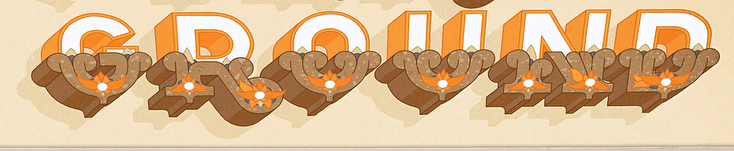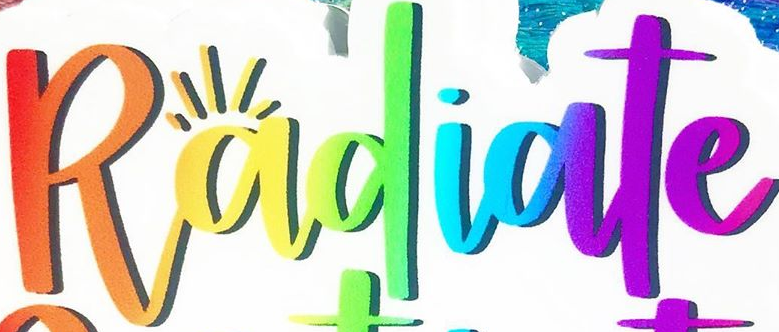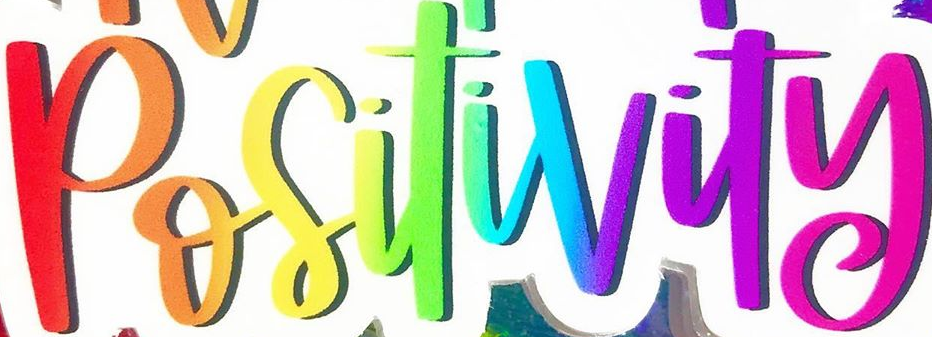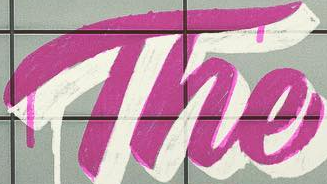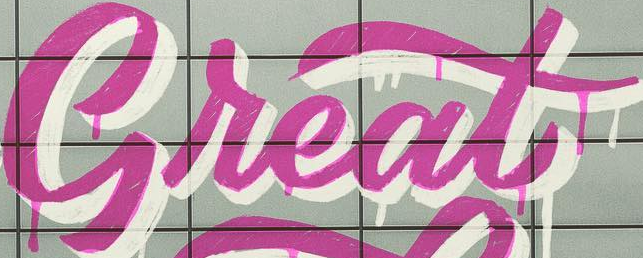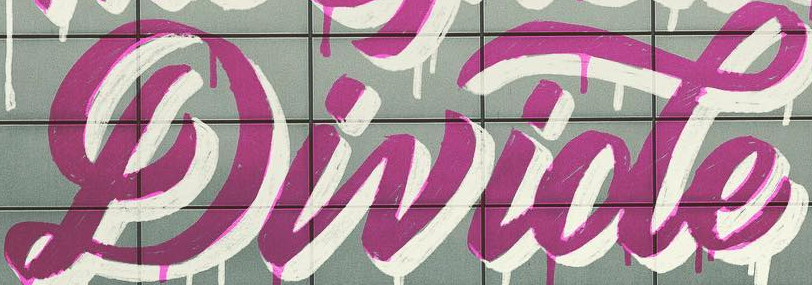What words can you see in these images in sequence, separated by a semicolon? GROUND; Radiate; Positivity; The; Great; Divide 